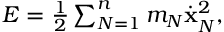<formula> <loc_0><loc_0><loc_500><loc_500>\begin{array} { r } { E = \frac { 1 } { 2 } \sum _ { N = 1 } ^ { n } m _ { N } \dot { x } _ { N } ^ { 2 } , } \end{array}</formula> 